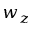Convert formula to latex. <formula><loc_0><loc_0><loc_500><loc_500>w _ { z }</formula> 